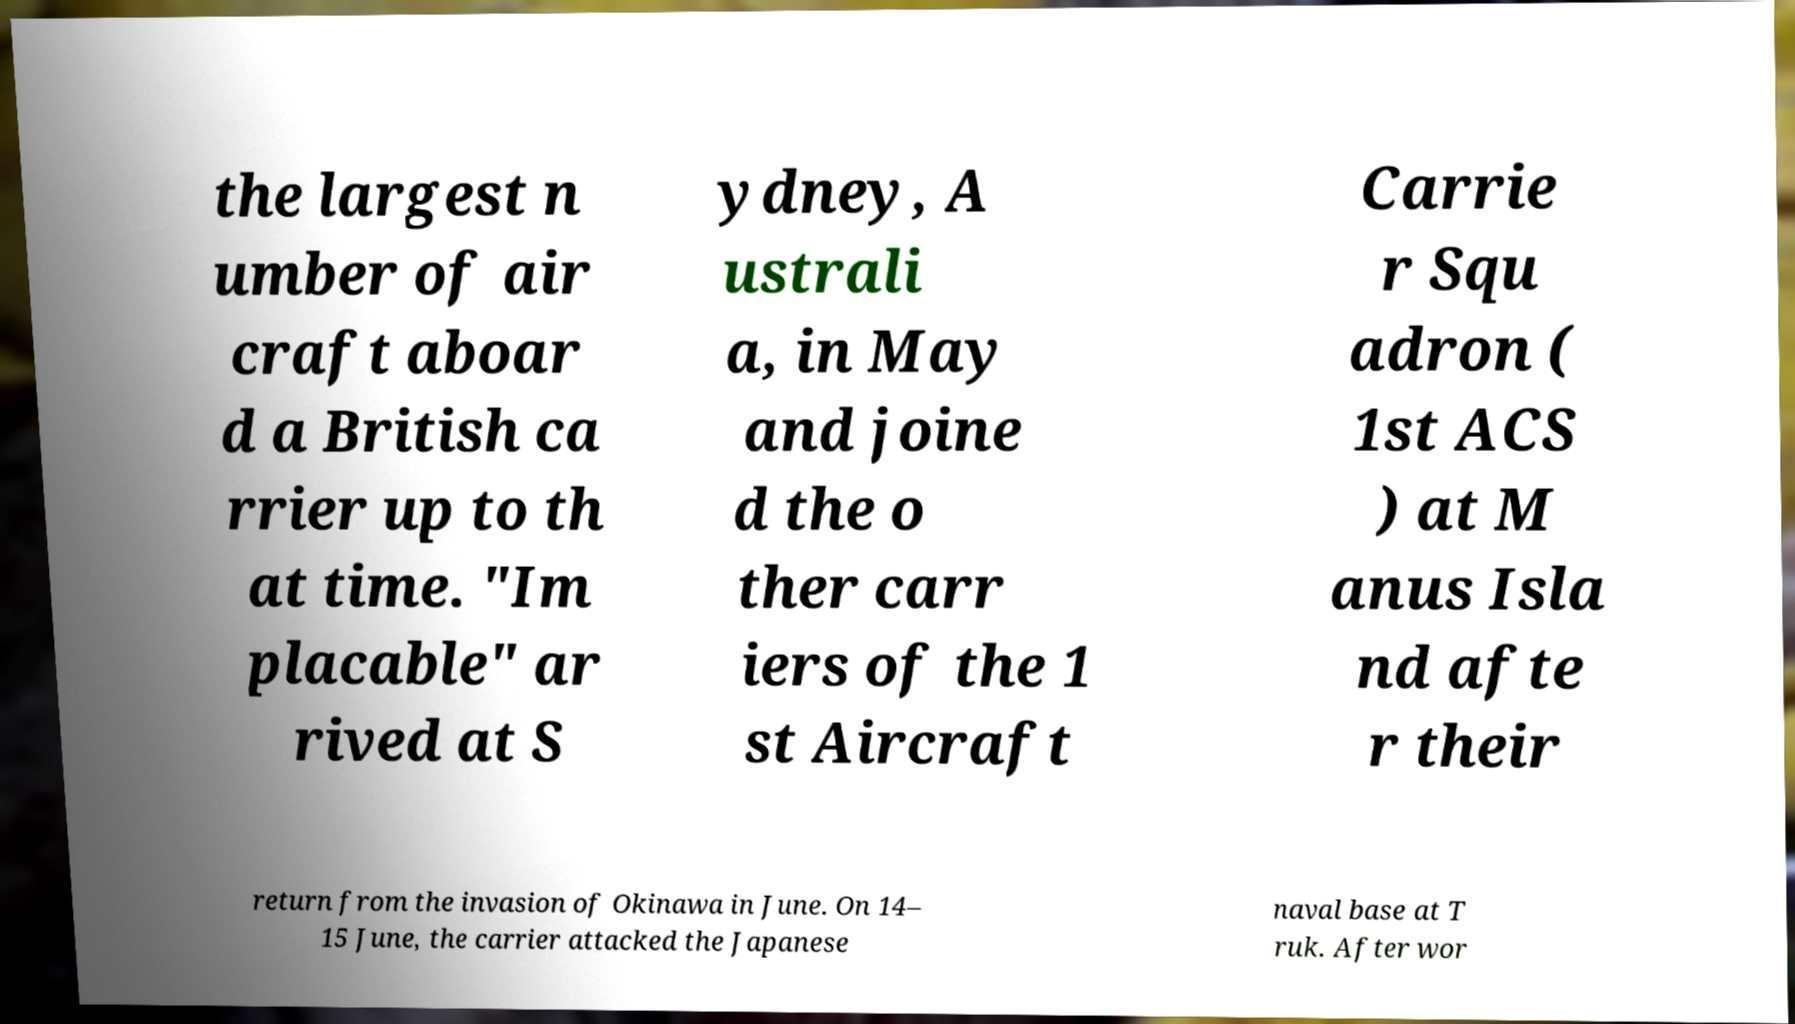For documentation purposes, I need the text within this image transcribed. Could you provide that? the largest n umber of air craft aboar d a British ca rrier up to th at time. "Im placable" ar rived at S ydney, A ustrali a, in May and joine d the o ther carr iers of the 1 st Aircraft Carrie r Squ adron ( 1st ACS ) at M anus Isla nd afte r their return from the invasion of Okinawa in June. On 14– 15 June, the carrier attacked the Japanese naval base at T ruk. After wor 